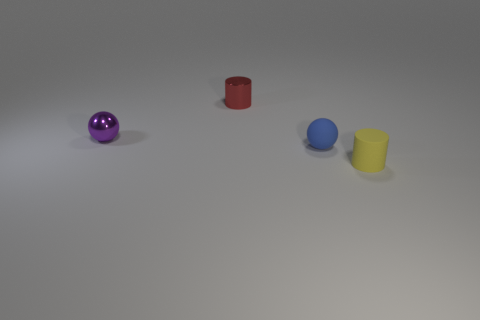There is a cylinder that is in front of the tiny red metal thing; does it have the same size as the ball that is to the left of the tiny red shiny object?
Provide a short and direct response. Yes. How many objects are yellow balls or shiny balls?
Keep it short and to the point. 1. What material is the small cylinder behind the sphere that is to the left of the matte ball?
Your response must be concise. Metal. What number of other things have the same shape as the red object?
Keep it short and to the point. 1. Are there any shiny things of the same color as the tiny metal ball?
Your answer should be very brief. No. How many objects are things on the left side of the yellow matte thing or objects in front of the small matte sphere?
Provide a short and direct response. 4. There is a tiny matte object that is left of the matte cylinder; is there a small matte sphere in front of it?
Provide a succinct answer. No. There is another matte object that is the same size as the blue thing; what is its shape?
Keep it short and to the point. Cylinder. What number of objects are either matte objects that are behind the yellow thing or red metallic cylinders?
Ensure brevity in your answer.  2. What number of other objects are there of the same material as the red cylinder?
Ensure brevity in your answer.  1. 